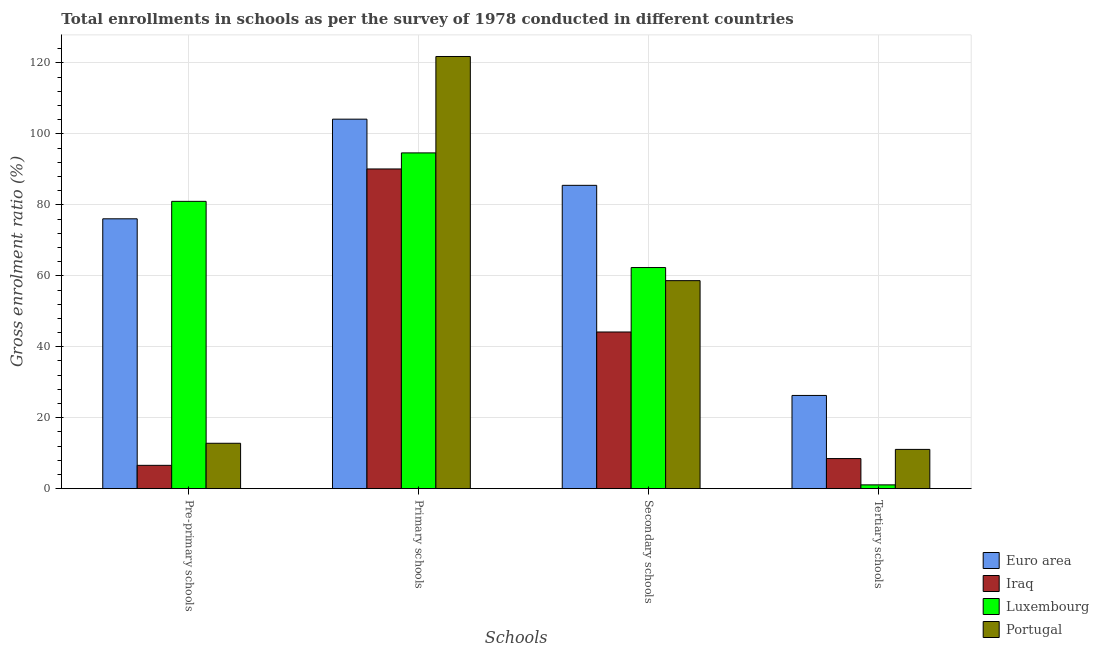Are the number of bars per tick equal to the number of legend labels?
Give a very brief answer. Yes. Are the number of bars on each tick of the X-axis equal?
Offer a terse response. Yes. How many bars are there on the 1st tick from the right?
Your answer should be very brief. 4. What is the label of the 2nd group of bars from the left?
Give a very brief answer. Primary schools. What is the gross enrolment ratio in primary schools in Iraq?
Give a very brief answer. 90.13. Across all countries, what is the maximum gross enrolment ratio in tertiary schools?
Give a very brief answer. 26.28. Across all countries, what is the minimum gross enrolment ratio in tertiary schools?
Make the answer very short. 1.07. In which country was the gross enrolment ratio in pre-primary schools maximum?
Provide a succinct answer. Luxembourg. In which country was the gross enrolment ratio in pre-primary schools minimum?
Keep it short and to the point. Iraq. What is the total gross enrolment ratio in tertiary schools in the graph?
Provide a succinct answer. 46.91. What is the difference between the gross enrolment ratio in tertiary schools in Portugal and that in Euro area?
Your response must be concise. -15.21. What is the difference between the gross enrolment ratio in secondary schools in Luxembourg and the gross enrolment ratio in tertiary schools in Iraq?
Keep it short and to the point. 53.85. What is the average gross enrolment ratio in secondary schools per country?
Give a very brief answer. 62.67. What is the difference between the gross enrolment ratio in tertiary schools and gross enrolment ratio in primary schools in Euro area?
Offer a very short reply. -77.88. In how many countries, is the gross enrolment ratio in tertiary schools greater than 12 %?
Provide a short and direct response. 1. What is the ratio of the gross enrolment ratio in pre-primary schools in Portugal to that in Luxembourg?
Provide a succinct answer. 0.16. Is the gross enrolment ratio in tertiary schools in Luxembourg less than that in Iraq?
Offer a terse response. Yes. Is the difference between the gross enrolment ratio in pre-primary schools in Iraq and Portugal greater than the difference between the gross enrolment ratio in primary schools in Iraq and Portugal?
Make the answer very short. Yes. What is the difference between the highest and the second highest gross enrolment ratio in tertiary schools?
Your answer should be very brief. 15.21. What is the difference between the highest and the lowest gross enrolment ratio in tertiary schools?
Give a very brief answer. 25.21. In how many countries, is the gross enrolment ratio in pre-primary schools greater than the average gross enrolment ratio in pre-primary schools taken over all countries?
Your answer should be very brief. 2. Is the sum of the gross enrolment ratio in pre-primary schools in Iraq and Luxembourg greater than the maximum gross enrolment ratio in primary schools across all countries?
Ensure brevity in your answer.  No. Is it the case that in every country, the sum of the gross enrolment ratio in tertiary schools and gross enrolment ratio in secondary schools is greater than the sum of gross enrolment ratio in pre-primary schools and gross enrolment ratio in primary schools?
Keep it short and to the point. No. What does the 3rd bar from the left in Secondary schools represents?
Offer a very short reply. Luxembourg. What does the 2nd bar from the right in Secondary schools represents?
Your answer should be very brief. Luxembourg. Is it the case that in every country, the sum of the gross enrolment ratio in pre-primary schools and gross enrolment ratio in primary schools is greater than the gross enrolment ratio in secondary schools?
Keep it short and to the point. Yes. How many bars are there?
Your answer should be compact. 16. Are all the bars in the graph horizontal?
Provide a short and direct response. No. Are the values on the major ticks of Y-axis written in scientific E-notation?
Provide a succinct answer. No. Does the graph contain any zero values?
Your answer should be compact. No. Does the graph contain grids?
Offer a terse response. Yes. Where does the legend appear in the graph?
Provide a short and direct response. Bottom right. How are the legend labels stacked?
Give a very brief answer. Vertical. What is the title of the graph?
Ensure brevity in your answer.  Total enrollments in schools as per the survey of 1978 conducted in different countries. Does "Bosnia and Herzegovina" appear as one of the legend labels in the graph?
Provide a short and direct response. No. What is the label or title of the X-axis?
Provide a succinct answer. Schools. What is the label or title of the Y-axis?
Your response must be concise. Gross enrolment ratio (%). What is the Gross enrolment ratio (%) of Euro area in Pre-primary schools?
Give a very brief answer. 76.07. What is the Gross enrolment ratio (%) of Iraq in Pre-primary schools?
Your response must be concise. 6.58. What is the Gross enrolment ratio (%) of Luxembourg in Pre-primary schools?
Your answer should be compact. 80.99. What is the Gross enrolment ratio (%) of Portugal in Pre-primary schools?
Offer a terse response. 12.8. What is the Gross enrolment ratio (%) in Euro area in Primary schools?
Your answer should be very brief. 104.16. What is the Gross enrolment ratio (%) of Iraq in Primary schools?
Your answer should be compact. 90.13. What is the Gross enrolment ratio (%) in Luxembourg in Primary schools?
Offer a very short reply. 94.65. What is the Gross enrolment ratio (%) of Portugal in Primary schools?
Make the answer very short. 121.83. What is the Gross enrolment ratio (%) in Euro area in Secondary schools?
Make the answer very short. 85.51. What is the Gross enrolment ratio (%) in Iraq in Secondary schools?
Give a very brief answer. 44.17. What is the Gross enrolment ratio (%) of Luxembourg in Secondary schools?
Provide a short and direct response. 62.34. What is the Gross enrolment ratio (%) of Portugal in Secondary schools?
Provide a succinct answer. 58.64. What is the Gross enrolment ratio (%) in Euro area in Tertiary schools?
Give a very brief answer. 26.28. What is the Gross enrolment ratio (%) of Iraq in Tertiary schools?
Provide a succinct answer. 8.49. What is the Gross enrolment ratio (%) in Luxembourg in Tertiary schools?
Keep it short and to the point. 1.07. What is the Gross enrolment ratio (%) in Portugal in Tertiary schools?
Your answer should be very brief. 11.07. Across all Schools, what is the maximum Gross enrolment ratio (%) of Euro area?
Your answer should be compact. 104.16. Across all Schools, what is the maximum Gross enrolment ratio (%) in Iraq?
Your answer should be compact. 90.13. Across all Schools, what is the maximum Gross enrolment ratio (%) of Luxembourg?
Your answer should be compact. 94.65. Across all Schools, what is the maximum Gross enrolment ratio (%) in Portugal?
Provide a short and direct response. 121.83. Across all Schools, what is the minimum Gross enrolment ratio (%) of Euro area?
Provide a succinct answer. 26.28. Across all Schools, what is the minimum Gross enrolment ratio (%) in Iraq?
Ensure brevity in your answer.  6.58. Across all Schools, what is the minimum Gross enrolment ratio (%) in Luxembourg?
Give a very brief answer. 1.07. Across all Schools, what is the minimum Gross enrolment ratio (%) in Portugal?
Your answer should be compact. 11.07. What is the total Gross enrolment ratio (%) in Euro area in the graph?
Offer a very short reply. 292.03. What is the total Gross enrolment ratio (%) in Iraq in the graph?
Your response must be concise. 149.36. What is the total Gross enrolment ratio (%) of Luxembourg in the graph?
Offer a very short reply. 239.06. What is the total Gross enrolment ratio (%) in Portugal in the graph?
Your answer should be compact. 204.35. What is the difference between the Gross enrolment ratio (%) in Euro area in Pre-primary schools and that in Primary schools?
Offer a terse response. -28.09. What is the difference between the Gross enrolment ratio (%) of Iraq in Pre-primary schools and that in Primary schools?
Your answer should be compact. -83.55. What is the difference between the Gross enrolment ratio (%) of Luxembourg in Pre-primary schools and that in Primary schools?
Offer a very short reply. -13.66. What is the difference between the Gross enrolment ratio (%) in Portugal in Pre-primary schools and that in Primary schools?
Give a very brief answer. -109.03. What is the difference between the Gross enrolment ratio (%) of Euro area in Pre-primary schools and that in Secondary schools?
Offer a terse response. -9.43. What is the difference between the Gross enrolment ratio (%) of Iraq in Pre-primary schools and that in Secondary schools?
Ensure brevity in your answer.  -37.59. What is the difference between the Gross enrolment ratio (%) of Luxembourg in Pre-primary schools and that in Secondary schools?
Provide a succinct answer. 18.65. What is the difference between the Gross enrolment ratio (%) of Portugal in Pre-primary schools and that in Secondary schools?
Give a very brief answer. -45.84. What is the difference between the Gross enrolment ratio (%) of Euro area in Pre-primary schools and that in Tertiary schools?
Provide a succinct answer. 49.79. What is the difference between the Gross enrolment ratio (%) of Iraq in Pre-primary schools and that in Tertiary schools?
Ensure brevity in your answer.  -1.9. What is the difference between the Gross enrolment ratio (%) of Luxembourg in Pre-primary schools and that in Tertiary schools?
Ensure brevity in your answer.  79.92. What is the difference between the Gross enrolment ratio (%) of Portugal in Pre-primary schools and that in Tertiary schools?
Keep it short and to the point. 1.73. What is the difference between the Gross enrolment ratio (%) in Euro area in Primary schools and that in Secondary schools?
Your answer should be compact. 18.65. What is the difference between the Gross enrolment ratio (%) of Iraq in Primary schools and that in Secondary schools?
Offer a terse response. 45.96. What is the difference between the Gross enrolment ratio (%) of Luxembourg in Primary schools and that in Secondary schools?
Offer a very short reply. 32.31. What is the difference between the Gross enrolment ratio (%) in Portugal in Primary schools and that in Secondary schools?
Offer a very short reply. 63.19. What is the difference between the Gross enrolment ratio (%) of Euro area in Primary schools and that in Tertiary schools?
Provide a succinct answer. 77.88. What is the difference between the Gross enrolment ratio (%) in Iraq in Primary schools and that in Tertiary schools?
Offer a terse response. 81.64. What is the difference between the Gross enrolment ratio (%) in Luxembourg in Primary schools and that in Tertiary schools?
Give a very brief answer. 93.58. What is the difference between the Gross enrolment ratio (%) in Portugal in Primary schools and that in Tertiary schools?
Your answer should be very brief. 110.76. What is the difference between the Gross enrolment ratio (%) in Euro area in Secondary schools and that in Tertiary schools?
Your answer should be compact. 59.23. What is the difference between the Gross enrolment ratio (%) in Iraq in Secondary schools and that in Tertiary schools?
Your answer should be very brief. 35.68. What is the difference between the Gross enrolment ratio (%) of Luxembourg in Secondary schools and that in Tertiary schools?
Ensure brevity in your answer.  61.26. What is the difference between the Gross enrolment ratio (%) in Portugal in Secondary schools and that in Tertiary schools?
Offer a terse response. 47.57. What is the difference between the Gross enrolment ratio (%) of Euro area in Pre-primary schools and the Gross enrolment ratio (%) of Iraq in Primary schools?
Give a very brief answer. -14.05. What is the difference between the Gross enrolment ratio (%) of Euro area in Pre-primary schools and the Gross enrolment ratio (%) of Luxembourg in Primary schools?
Keep it short and to the point. -18.58. What is the difference between the Gross enrolment ratio (%) in Euro area in Pre-primary schools and the Gross enrolment ratio (%) in Portugal in Primary schools?
Offer a terse response. -45.76. What is the difference between the Gross enrolment ratio (%) in Iraq in Pre-primary schools and the Gross enrolment ratio (%) in Luxembourg in Primary schools?
Give a very brief answer. -88.07. What is the difference between the Gross enrolment ratio (%) of Iraq in Pre-primary schools and the Gross enrolment ratio (%) of Portugal in Primary schools?
Your answer should be very brief. -115.25. What is the difference between the Gross enrolment ratio (%) of Luxembourg in Pre-primary schools and the Gross enrolment ratio (%) of Portugal in Primary schools?
Give a very brief answer. -40.84. What is the difference between the Gross enrolment ratio (%) in Euro area in Pre-primary schools and the Gross enrolment ratio (%) in Iraq in Secondary schools?
Provide a short and direct response. 31.9. What is the difference between the Gross enrolment ratio (%) in Euro area in Pre-primary schools and the Gross enrolment ratio (%) in Luxembourg in Secondary schools?
Make the answer very short. 13.74. What is the difference between the Gross enrolment ratio (%) of Euro area in Pre-primary schools and the Gross enrolment ratio (%) of Portugal in Secondary schools?
Provide a short and direct response. 17.43. What is the difference between the Gross enrolment ratio (%) in Iraq in Pre-primary schools and the Gross enrolment ratio (%) in Luxembourg in Secondary schools?
Your response must be concise. -55.76. What is the difference between the Gross enrolment ratio (%) in Iraq in Pre-primary schools and the Gross enrolment ratio (%) in Portugal in Secondary schools?
Your answer should be compact. -52.06. What is the difference between the Gross enrolment ratio (%) in Luxembourg in Pre-primary schools and the Gross enrolment ratio (%) in Portugal in Secondary schools?
Offer a terse response. 22.35. What is the difference between the Gross enrolment ratio (%) of Euro area in Pre-primary schools and the Gross enrolment ratio (%) of Iraq in Tertiary schools?
Provide a succinct answer. 67.59. What is the difference between the Gross enrolment ratio (%) in Euro area in Pre-primary schools and the Gross enrolment ratio (%) in Luxembourg in Tertiary schools?
Provide a short and direct response. 75. What is the difference between the Gross enrolment ratio (%) of Euro area in Pre-primary schools and the Gross enrolment ratio (%) of Portugal in Tertiary schools?
Provide a short and direct response. 65. What is the difference between the Gross enrolment ratio (%) of Iraq in Pre-primary schools and the Gross enrolment ratio (%) of Luxembourg in Tertiary schools?
Your answer should be compact. 5.51. What is the difference between the Gross enrolment ratio (%) in Iraq in Pre-primary schools and the Gross enrolment ratio (%) in Portugal in Tertiary schools?
Your response must be concise. -4.49. What is the difference between the Gross enrolment ratio (%) in Luxembourg in Pre-primary schools and the Gross enrolment ratio (%) in Portugal in Tertiary schools?
Give a very brief answer. 69.92. What is the difference between the Gross enrolment ratio (%) of Euro area in Primary schools and the Gross enrolment ratio (%) of Iraq in Secondary schools?
Provide a short and direct response. 59.99. What is the difference between the Gross enrolment ratio (%) in Euro area in Primary schools and the Gross enrolment ratio (%) in Luxembourg in Secondary schools?
Your response must be concise. 41.82. What is the difference between the Gross enrolment ratio (%) of Euro area in Primary schools and the Gross enrolment ratio (%) of Portugal in Secondary schools?
Offer a very short reply. 45.52. What is the difference between the Gross enrolment ratio (%) of Iraq in Primary schools and the Gross enrolment ratio (%) of Luxembourg in Secondary schools?
Your response must be concise. 27.79. What is the difference between the Gross enrolment ratio (%) of Iraq in Primary schools and the Gross enrolment ratio (%) of Portugal in Secondary schools?
Keep it short and to the point. 31.48. What is the difference between the Gross enrolment ratio (%) of Luxembourg in Primary schools and the Gross enrolment ratio (%) of Portugal in Secondary schools?
Ensure brevity in your answer.  36.01. What is the difference between the Gross enrolment ratio (%) in Euro area in Primary schools and the Gross enrolment ratio (%) in Iraq in Tertiary schools?
Offer a very short reply. 95.68. What is the difference between the Gross enrolment ratio (%) of Euro area in Primary schools and the Gross enrolment ratio (%) of Luxembourg in Tertiary schools?
Offer a very short reply. 103.09. What is the difference between the Gross enrolment ratio (%) in Euro area in Primary schools and the Gross enrolment ratio (%) in Portugal in Tertiary schools?
Offer a terse response. 93.09. What is the difference between the Gross enrolment ratio (%) of Iraq in Primary schools and the Gross enrolment ratio (%) of Luxembourg in Tertiary schools?
Your answer should be very brief. 89.05. What is the difference between the Gross enrolment ratio (%) in Iraq in Primary schools and the Gross enrolment ratio (%) in Portugal in Tertiary schools?
Keep it short and to the point. 79.05. What is the difference between the Gross enrolment ratio (%) of Luxembourg in Primary schools and the Gross enrolment ratio (%) of Portugal in Tertiary schools?
Provide a short and direct response. 83.58. What is the difference between the Gross enrolment ratio (%) in Euro area in Secondary schools and the Gross enrolment ratio (%) in Iraq in Tertiary schools?
Offer a very short reply. 77.02. What is the difference between the Gross enrolment ratio (%) of Euro area in Secondary schools and the Gross enrolment ratio (%) of Luxembourg in Tertiary schools?
Your response must be concise. 84.43. What is the difference between the Gross enrolment ratio (%) of Euro area in Secondary schools and the Gross enrolment ratio (%) of Portugal in Tertiary schools?
Make the answer very short. 74.43. What is the difference between the Gross enrolment ratio (%) in Iraq in Secondary schools and the Gross enrolment ratio (%) in Luxembourg in Tertiary schools?
Offer a very short reply. 43.1. What is the difference between the Gross enrolment ratio (%) in Iraq in Secondary schools and the Gross enrolment ratio (%) in Portugal in Tertiary schools?
Your answer should be compact. 33.1. What is the difference between the Gross enrolment ratio (%) of Luxembourg in Secondary schools and the Gross enrolment ratio (%) of Portugal in Tertiary schools?
Give a very brief answer. 51.27. What is the average Gross enrolment ratio (%) in Euro area per Schools?
Your response must be concise. 73.01. What is the average Gross enrolment ratio (%) in Iraq per Schools?
Offer a very short reply. 37.34. What is the average Gross enrolment ratio (%) in Luxembourg per Schools?
Your answer should be very brief. 59.77. What is the average Gross enrolment ratio (%) in Portugal per Schools?
Keep it short and to the point. 51.09. What is the difference between the Gross enrolment ratio (%) in Euro area and Gross enrolment ratio (%) in Iraq in Pre-primary schools?
Your response must be concise. 69.49. What is the difference between the Gross enrolment ratio (%) in Euro area and Gross enrolment ratio (%) in Luxembourg in Pre-primary schools?
Your answer should be compact. -4.92. What is the difference between the Gross enrolment ratio (%) in Euro area and Gross enrolment ratio (%) in Portugal in Pre-primary schools?
Your response must be concise. 63.28. What is the difference between the Gross enrolment ratio (%) in Iraq and Gross enrolment ratio (%) in Luxembourg in Pre-primary schools?
Keep it short and to the point. -74.41. What is the difference between the Gross enrolment ratio (%) of Iraq and Gross enrolment ratio (%) of Portugal in Pre-primary schools?
Provide a short and direct response. -6.22. What is the difference between the Gross enrolment ratio (%) in Luxembourg and Gross enrolment ratio (%) in Portugal in Pre-primary schools?
Your answer should be very brief. 68.19. What is the difference between the Gross enrolment ratio (%) in Euro area and Gross enrolment ratio (%) in Iraq in Primary schools?
Offer a very short reply. 14.03. What is the difference between the Gross enrolment ratio (%) of Euro area and Gross enrolment ratio (%) of Luxembourg in Primary schools?
Provide a short and direct response. 9.51. What is the difference between the Gross enrolment ratio (%) in Euro area and Gross enrolment ratio (%) in Portugal in Primary schools?
Give a very brief answer. -17.67. What is the difference between the Gross enrolment ratio (%) of Iraq and Gross enrolment ratio (%) of Luxembourg in Primary schools?
Your answer should be compact. -4.53. What is the difference between the Gross enrolment ratio (%) of Iraq and Gross enrolment ratio (%) of Portugal in Primary schools?
Your response must be concise. -31.7. What is the difference between the Gross enrolment ratio (%) of Luxembourg and Gross enrolment ratio (%) of Portugal in Primary schools?
Offer a very short reply. -27.18. What is the difference between the Gross enrolment ratio (%) of Euro area and Gross enrolment ratio (%) of Iraq in Secondary schools?
Your answer should be very brief. 41.34. What is the difference between the Gross enrolment ratio (%) of Euro area and Gross enrolment ratio (%) of Luxembourg in Secondary schools?
Provide a short and direct response. 23.17. What is the difference between the Gross enrolment ratio (%) of Euro area and Gross enrolment ratio (%) of Portugal in Secondary schools?
Provide a succinct answer. 26.86. What is the difference between the Gross enrolment ratio (%) in Iraq and Gross enrolment ratio (%) in Luxembourg in Secondary schools?
Your answer should be very brief. -18.17. What is the difference between the Gross enrolment ratio (%) in Iraq and Gross enrolment ratio (%) in Portugal in Secondary schools?
Your response must be concise. -14.47. What is the difference between the Gross enrolment ratio (%) in Luxembourg and Gross enrolment ratio (%) in Portugal in Secondary schools?
Your answer should be very brief. 3.7. What is the difference between the Gross enrolment ratio (%) in Euro area and Gross enrolment ratio (%) in Iraq in Tertiary schools?
Provide a short and direct response. 17.8. What is the difference between the Gross enrolment ratio (%) in Euro area and Gross enrolment ratio (%) in Luxembourg in Tertiary schools?
Provide a succinct answer. 25.21. What is the difference between the Gross enrolment ratio (%) in Euro area and Gross enrolment ratio (%) in Portugal in Tertiary schools?
Your answer should be very brief. 15.21. What is the difference between the Gross enrolment ratio (%) in Iraq and Gross enrolment ratio (%) in Luxembourg in Tertiary schools?
Make the answer very short. 7.41. What is the difference between the Gross enrolment ratio (%) in Iraq and Gross enrolment ratio (%) in Portugal in Tertiary schools?
Your response must be concise. -2.59. What is the difference between the Gross enrolment ratio (%) in Luxembourg and Gross enrolment ratio (%) in Portugal in Tertiary schools?
Ensure brevity in your answer.  -10. What is the ratio of the Gross enrolment ratio (%) of Euro area in Pre-primary schools to that in Primary schools?
Ensure brevity in your answer.  0.73. What is the ratio of the Gross enrolment ratio (%) of Iraq in Pre-primary schools to that in Primary schools?
Provide a succinct answer. 0.07. What is the ratio of the Gross enrolment ratio (%) of Luxembourg in Pre-primary schools to that in Primary schools?
Your answer should be compact. 0.86. What is the ratio of the Gross enrolment ratio (%) of Portugal in Pre-primary schools to that in Primary schools?
Keep it short and to the point. 0.11. What is the ratio of the Gross enrolment ratio (%) of Euro area in Pre-primary schools to that in Secondary schools?
Give a very brief answer. 0.89. What is the ratio of the Gross enrolment ratio (%) of Iraq in Pre-primary schools to that in Secondary schools?
Offer a terse response. 0.15. What is the ratio of the Gross enrolment ratio (%) in Luxembourg in Pre-primary schools to that in Secondary schools?
Keep it short and to the point. 1.3. What is the ratio of the Gross enrolment ratio (%) of Portugal in Pre-primary schools to that in Secondary schools?
Provide a succinct answer. 0.22. What is the ratio of the Gross enrolment ratio (%) of Euro area in Pre-primary schools to that in Tertiary schools?
Provide a succinct answer. 2.89. What is the ratio of the Gross enrolment ratio (%) of Iraq in Pre-primary schools to that in Tertiary schools?
Your answer should be very brief. 0.78. What is the ratio of the Gross enrolment ratio (%) of Luxembourg in Pre-primary schools to that in Tertiary schools?
Keep it short and to the point. 75.38. What is the ratio of the Gross enrolment ratio (%) of Portugal in Pre-primary schools to that in Tertiary schools?
Provide a short and direct response. 1.16. What is the ratio of the Gross enrolment ratio (%) of Euro area in Primary schools to that in Secondary schools?
Give a very brief answer. 1.22. What is the ratio of the Gross enrolment ratio (%) in Iraq in Primary schools to that in Secondary schools?
Your response must be concise. 2.04. What is the ratio of the Gross enrolment ratio (%) in Luxembourg in Primary schools to that in Secondary schools?
Your answer should be compact. 1.52. What is the ratio of the Gross enrolment ratio (%) of Portugal in Primary schools to that in Secondary schools?
Your response must be concise. 2.08. What is the ratio of the Gross enrolment ratio (%) of Euro area in Primary schools to that in Tertiary schools?
Your response must be concise. 3.96. What is the ratio of the Gross enrolment ratio (%) of Iraq in Primary schools to that in Tertiary schools?
Provide a succinct answer. 10.62. What is the ratio of the Gross enrolment ratio (%) in Luxembourg in Primary schools to that in Tertiary schools?
Give a very brief answer. 88.09. What is the ratio of the Gross enrolment ratio (%) in Portugal in Primary schools to that in Tertiary schools?
Offer a terse response. 11. What is the ratio of the Gross enrolment ratio (%) of Euro area in Secondary schools to that in Tertiary schools?
Offer a very short reply. 3.25. What is the ratio of the Gross enrolment ratio (%) of Iraq in Secondary schools to that in Tertiary schools?
Offer a very short reply. 5.21. What is the ratio of the Gross enrolment ratio (%) in Luxembourg in Secondary schools to that in Tertiary schools?
Make the answer very short. 58.01. What is the ratio of the Gross enrolment ratio (%) in Portugal in Secondary schools to that in Tertiary schools?
Offer a very short reply. 5.3. What is the difference between the highest and the second highest Gross enrolment ratio (%) of Euro area?
Your response must be concise. 18.65. What is the difference between the highest and the second highest Gross enrolment ratio (%) in Iraq?
Give a very brief answer. 45.96. What is the difference between the highest and the second highest Gross enrolment ratio (%) in Luxembourg?
Provide a succinct answer. 13.66. What is the difference between the highest and the second highest Gross enrolment ratio (%) of Portugal?
Your answer should be very brief. 63.19. What is the difference between the highest and the lowest Gross enrolment ratio (%) in Euro area?
Your answer should be very brief. 77.88. What is the difference between the highest and the lowest Gross enrolment ratio (%) in Iraq?
Ensure brevity in your answer.  83.55. What is the difference between the highest and the lowest Gross enrolment ratio (%) in Luxembourg?
Offer a very short reply. 93.58. What is the difference between the highest and the lowest Gross enrolment ratio (%) in Portugal?
Your answer should be very brief. 110.76. 